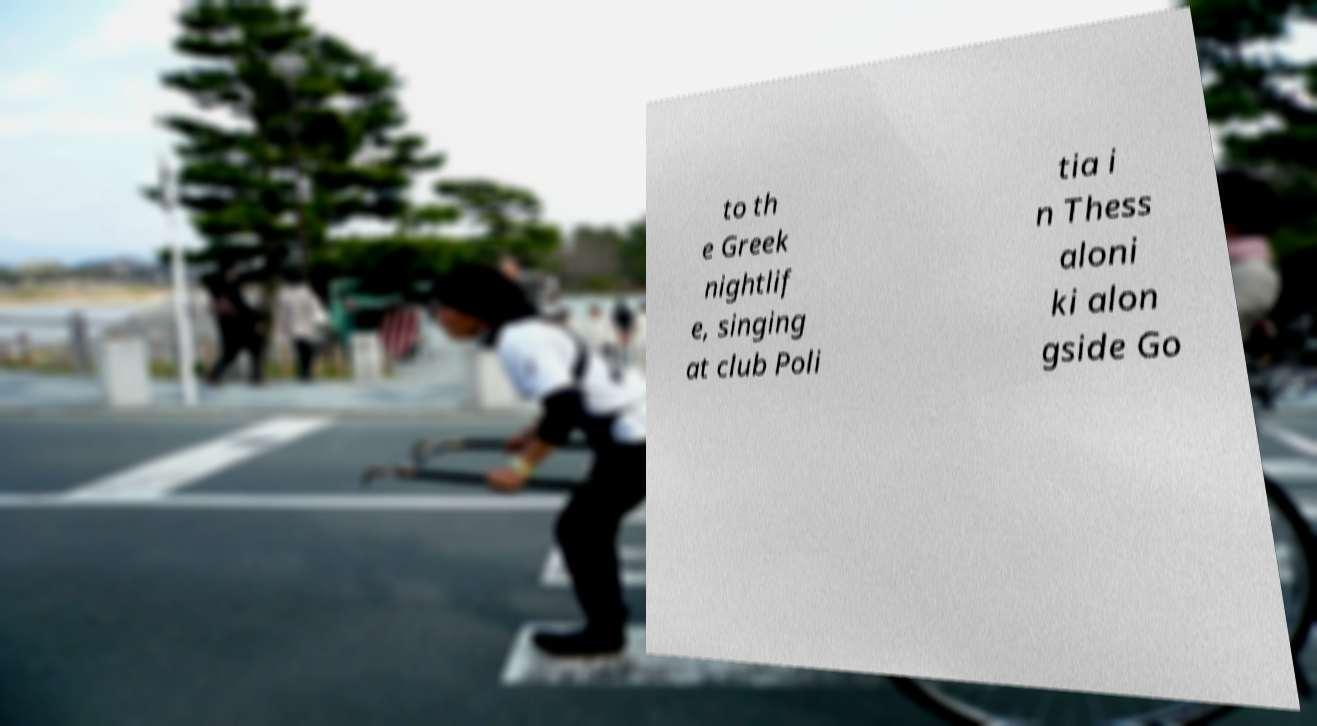Could you assist in decoding the text presented in this image and type it out clearly? to th e Greek nightlif e, singing at club Poli tia i n Thess aloni ki alon gside Go 